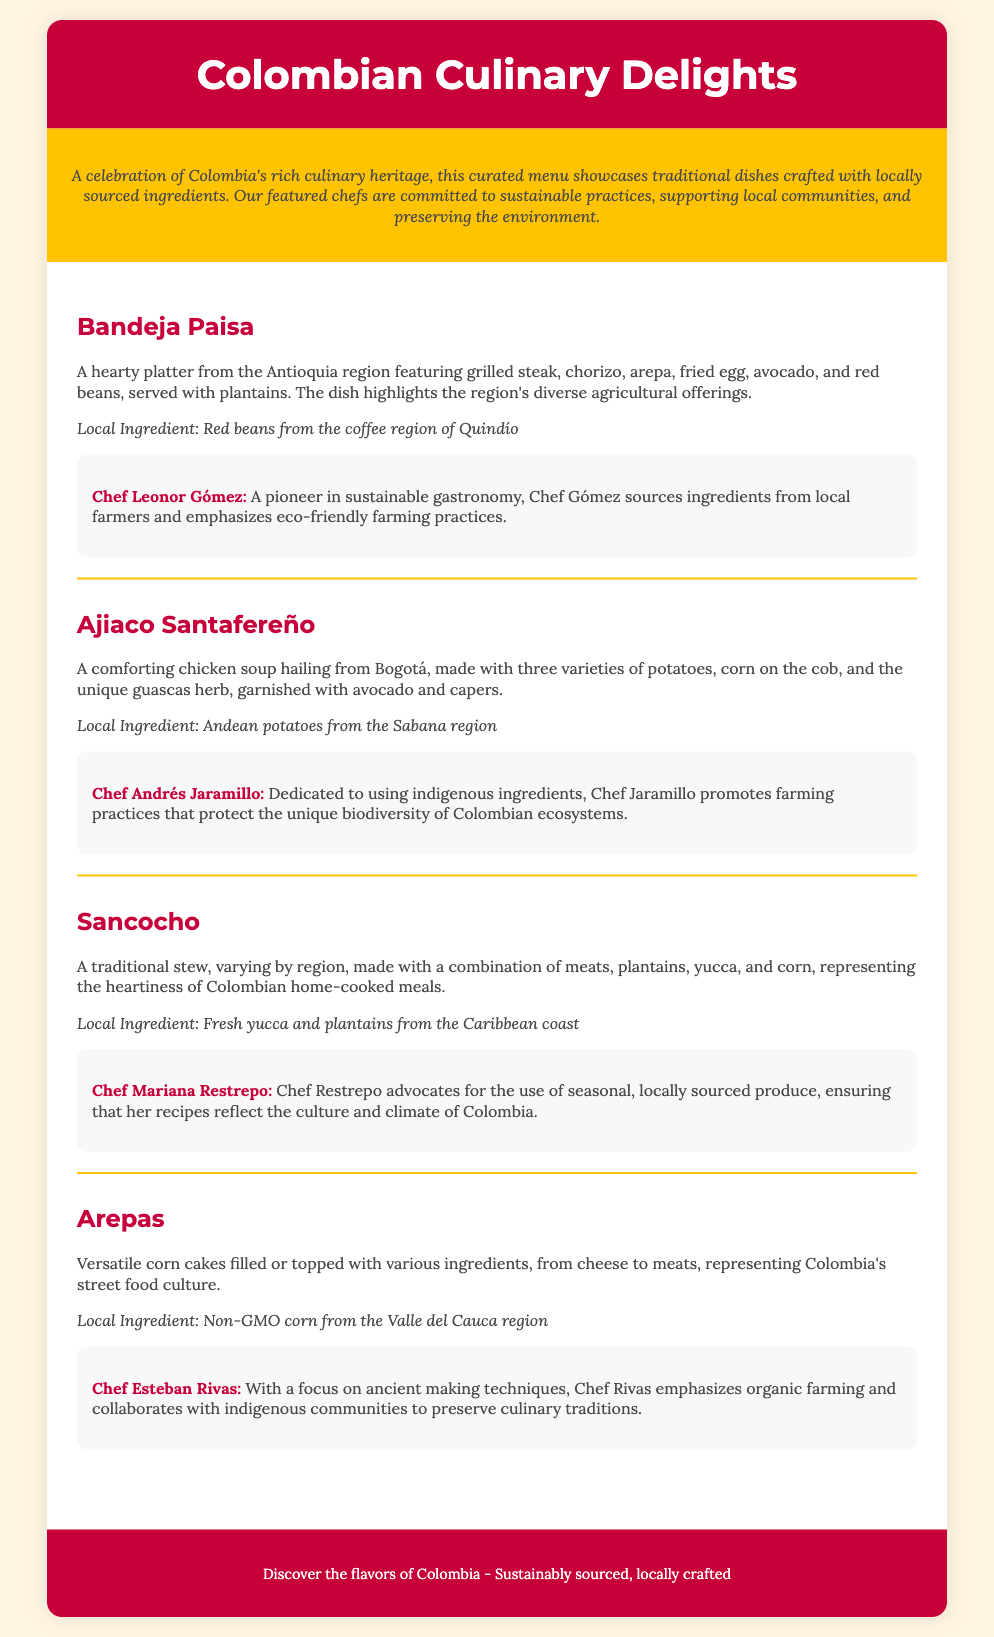What is the title of the menu? The title is prominently displayed at the top of the document in a large font, which reads "Colombian Culinary Delights."
Answer: Colombian Culinary Delights Who is the chef for Bandeja Paisa? The document lists the chef associated with each dish, and Bandeja Paisa is prepared by Chef Leonor Gómez.
Answer: Chef Leonor Gómez What local ingredient is used in Ajiaco Santafereño? Each dish highlights a specific local ingredient, and for Ajiaco Santafereño, it is Andean potatoes from the Sabana region.
Answer: Andean potatoes How many types of potatoes are used in Ajiaco Santafereño? The description of Ajiaco Santafereño states it is made with three varieties of potatoes.
Answer: Three What commitment does Chef Mariana Restrepo emphasize? She advocates for the use of seasonal, locally sourced produce, ensuring her recipes reflect the culture and climate of Colombia.
Answer: Seasonal produce Which dish represents Colombia's street food culture? The document specifies that Arepas are a versatile corn cake that embodies Colombia's street food culture.
Answer: Arepas What color is the background of the header? The header's background color is mentioned in the CSS styles, which is a strong red color (C70039).
Answer: Red What region does the local ingredient for Sancocho come from? The dish Sancocho features fresh yucca and plantains sourced from the Caribbean coast, as noted in the local ingredient section.
Answer: Caribbean coast What type of corn is used in Arepas? The document specifies that Arepas are made with non-GMO corn from the Valle del Cauca region.
Answer: Non-GMO corn 